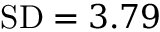<formula> <loc_0><loc_0><loc_500><loc_500>{ S D } = 3 . 7 9</formula> 